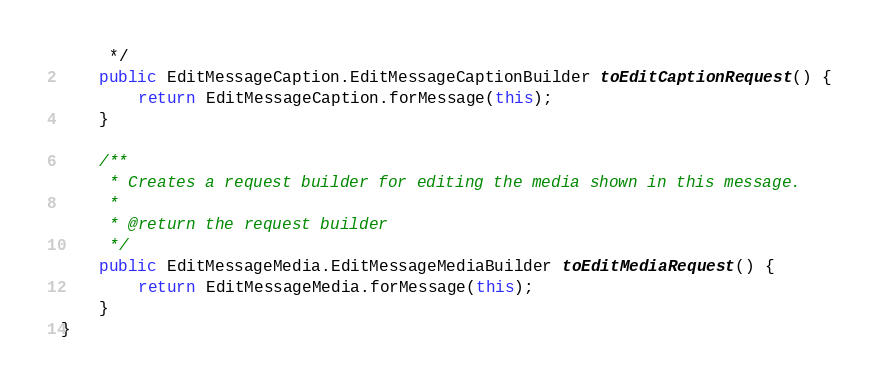Convert code to text. <code><loc_0><loc_0><loc_500><loc_500><_Java_>     */
    public EditMessageCaption.EditMessageCaptionBuilder toEditCaptionRequest() {
        return EditMessageCaption.forMessage(this);
    }

    /**
     * Creates a request builder for editing the media shown in this message.
     *
     * @return the request builder
     */
    public EditMessageMedia.EditMessageMediaBuilder toEditMediaRequest() {
        return EditMessageMedia.forMessage(this);
    }
}
</code> 